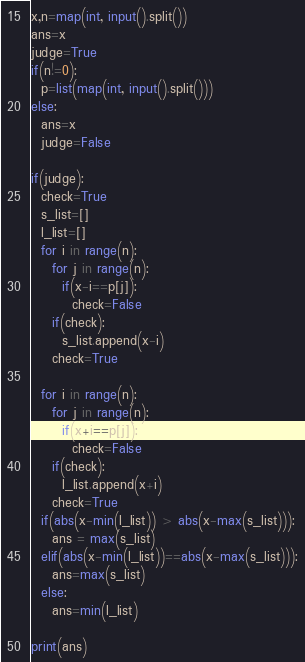Convert code to text. <code><loc_0><loc_0><loc_500><loc_500><_Python_>x,n=map(int, input().split())
ans=x
judge=True
if(n!=0):
  p=list(map(int, input().split()))
else:
  ans=x
  judge=False

if(judge):
  check=True
  s_list=[]
  l_list=[]
  for i in range(n):
    for j in range(n):
      if(x-i==p[j]):
        check=False
    if(check):
      s_list.append(x-i)
    check=True

  for i in range(n):
    for j in range(n):
      if(x+i==p[j]):
        check=False
    if(check):
      l_list.append(x+i)
    check=True
  if(abs(x-min(l_list)) > abs(x-max(s_list))):
    ans = max(s_list)
  elif(abs(x-min(l_list))==abs(x-max(s_list))):
    ans=max(s_list)
  else:
    ans=min(l_list)
  
print(ans)</code> 